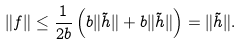Convert formula to latex. <formula><loc_0><loc_0><loc_500><loc_500>\| f \| \leq \frac { 1 } { 2 b } \left ( b \| \tilde { h } \| + b \| \tilde { h } \| \right ) = \| \tilde { h } \| .</formula> 